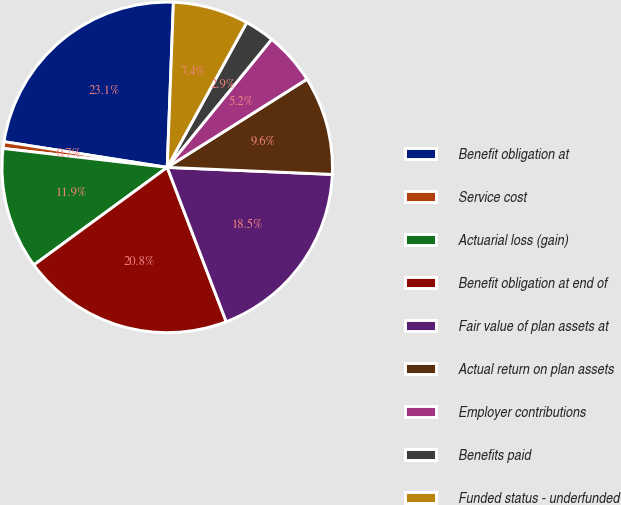<chart> <loc_0><loc_0><loc_500><loc_500><pie_chart><fcel>Benefit obligation at<fcel>Service cost<fcel>Actuarial loss (gain)<fcel>Benefit obligation at end of<fcel>Fair value of plan assets at<fcel>Actual return on plan assets<fcel>Employer contributions<fcel>Benefits paid<fcel>Funded status - underfunded<nl><fcel>23.11%<fcel>0.66%<fcel>11.88%<fcel>20.76%<fcel>18.51%<fcel>9.64%<fcel>5.15%<fcel>2.9%<fcel>7.39%<nl></chart> 